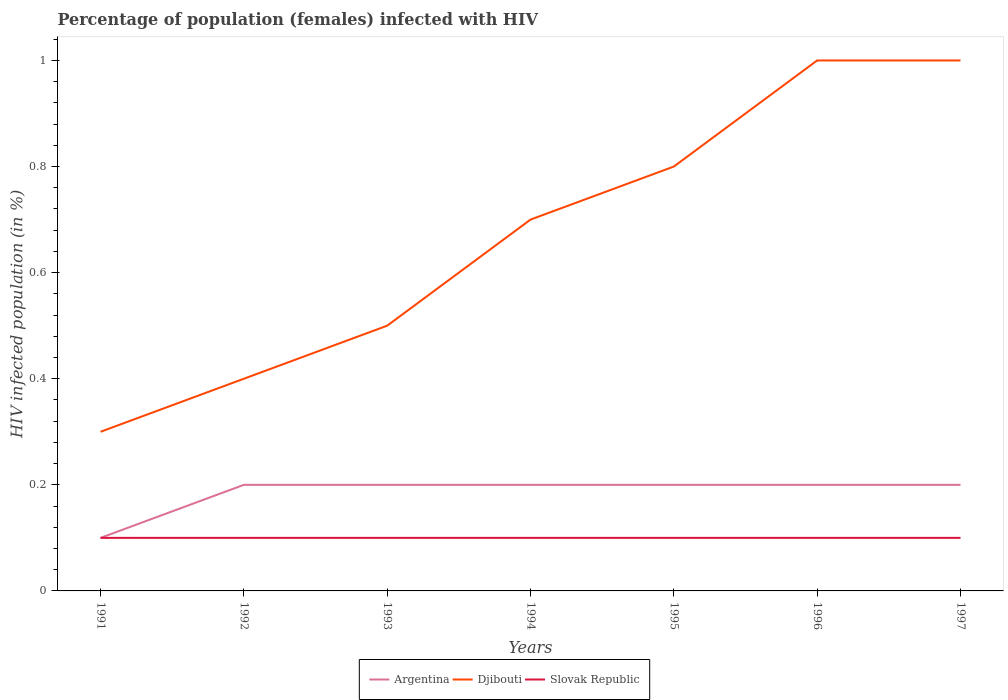Does the line corresponding to Djibouti intersect with the line corresponding to Slovak Republic?
Your response must be concise. No. Across all years, what is the maximum percentage of HIV infected female population in Argentina?
Give a very brief answer. 0.1. Is the percentage of HIV infected female population in Djibouti strictly greater than the percentage of HIV infected female population in Argentina over the years?
Offer a very short reply. No. Does the graph contain any zero values?
Give a very brief answer. No. Does the graph contain grids?
Offer a very short reply. No. Where does the legend appear in the graph?
Provide a succinct answer. Bottom center. How many legend labels are there?
Keep it short and to the point. 3. How are the legend labels stacked?
Provide a short and direct response. Horizontal. What is the title of the graph?
Give a very brief answer. Percentage of population (females) infected with HIV. Does "Vanuatu" appear as one of the legend labels in the graph?
Your answer should be very brief. No. What is the label or title of the Y-axis?
Give a very brief answer. HIV infected population (in %). What is the HIV infected population (in %) in Argentina in 1991?
Provide a short and direct response. 0.1. What is the HIV infected population (in %) in Djibouti in 1991?
Offer a terse response. 0.3. What is the HIV infected population (in %) in Slovak Republic in 1991?
Your answer should be compact. 0.1. What is the HIV infected population (in %) of Argentina in 1993?
Offer a terse response. 0.2. What is the HIV infected population (in %) of Slovak Republic in 1993?
Your answer should be compact. 0.1. What is the HIV infected population (in %) in Djibouti in 1994?
Make the answer very short. 0.7. What is the HIV infected population (in %) in Argentina in 1996?
Provide a succinct answer. 0.2. What is the HIV infected population (in %) in Slovak Republic in 1996?
Your answer should be very brief. 0.1. What is the HIV infected population (in %) of Argentina in 1997?
Offer a very short reply. 0.2. What is the HIV infected population (in %) of Djibouti in 1997?
Offer a terse response. 1. Across all years, what is the maximum HIV infected population (in %) in Djibouti?
Your answer should be very brief. 1. Across all years, what is the maximum HIV infected population (in %) in Slovak Republic?
Ensure brevity in your answer.  0.1. Across all years, what is the minimum HIV infected population (in %) of Argentina?
Offer a very short reply. 0.1. Across all years, what is the minimum HIV infected population (in %) of Slovak Republic?
Make the answer very short. 0.1. What is the total HIV infected population (in %) in Slovak Republic in the graph?
Your answer should be very brief. 0.7. What is the difference between the HIV infected population (in %) in Argentina in 1991 and that in 1992?
Offer a very short reply. -0.1. What is the difference between the HIV infected population (in %) in Slovak Republic in 1991 and that in 1993?
Offer a very short reply. 0. What is the difference between the HIV infected population (in %) of Argentina in 1991 and that in 1994?
Make the answer very short. -0.1. What is the difference between the HIV infected population (in %) in Djibouti in 1991 and that in 1995?
Offer a very short reply. -0.5. What is the difference between the HIV infected population (in %) of Slovak Republic in 1991 and that in 1995?
Your answer should be compact. 0. What is the difference between the HIV infected population (in %) in Djibouti in 1991 and that in 1996?
Keep it short and to the point. -0.7. What is the difference between the HIV infected population (in %) in Slovak Republic in 1991 and that in 1996?
Make the answer very short. 0. What is the difference between the HIV infected population (in %) of Djibouti in 1991 and that in 1997?
Your response must be concise. -0.7. What is the difference between the HIV infected population (in %) in Argentina in 1992 and that in 1993?
Give a very brief answer. 0. What is the difference between the HIV infected population (in %) in Slovak Republic in 1992 and that in 1993?
Your answer should be very brief. 0. What is the difference between the HIV infected population (in %) in Argentina in 1992 and that in 1994?
Offer a terse response. 0. What is the difference between the HIV infected population (in %) of Djibouti in 1992 and that in 1995?
Offer a very short reply. -0.4. What is the difference between the HIV infected population (in %) in Slovak Republic in 1992 and that in 1995?
Your answer should be compact. 0. What is the difference between the HIV infected population (in %) of Djibouti in 1992 and that in 1996?
Keep it short and to the point. -0.6. What is the difference between the HIV infected population (in %) in Argentina in 1992 and that in 1997?
Provide a succinct answer. 0. What is the difference between the HIV infected population (in %) of Slovak Republic in 1993 and that in 1994?
Your answer should be compact. 0. What is the difference between the HIV infected population (in %) in Djibouti in 1993 and that in 1995?
Keep it short and to the point. -0.3. What is the difference between the HIV infected population (in %) of Argentina in 1993 and that in 1996?
Offer a terse response. 0. What is the difference between the HIV infected population (in %) in Slovak Republic in 1993 and that in 1996?
Ensure brevity in your answer.  0. What is the difference between the HIV infected population (in %) of Argentina in 1993 and that in 1997?
Your answer should be very brief. 0. What is the difference between the HIV infected population (in %) in Djibouti in 1993 and that in 1997?
Make the answer very short. -0.5. What is the difference between the HIV infected population (in %) of Slovak Republic in 1993 and that in 1997?
Give a very brief answer. 0. What is the difference between the HIV infected population (in %) of Argentina in 1994 and that in 1995?
Provide a short and direct response. 0. What is the difference between the HIV infected population (in %) in Djibouti in 1994 and that in 1995?
Keep it short and to the point. -0.1. What is the difference between the HIV infected population (in %) of Argentina in 1994 and that in 1997?
Keep it short and to the point. 0. What is the difference between the HIV infected population (in %) of Slovak Republic in 1994 and that in 1997?
Offer a very short reply. 0. What is the difference between the HIV infected population (in %) in Djibouti in 1995 and that in 1996?
Your answer should be very brief. -0.2. What is the difference between the HIV infected population (in %) in Argentina in 1995 and that in 1997?
Offer a very short reply. 0. What is the difference between the HIV infected population (in %) in Djibouti in 1995 and that in 1997?
Offer a very short reply. -0.2. What is the difference between the HIV infected population (in %) of Djibouti in 1996 and that in 1997?
Provide a succinct answer. 0. What is the difference between the HIV infected population (in %) in Slovak Republic in 1996 and that in 1997?
Offer a very short reply. 0. What is the difference between the HIV infected population (in %) of Argentina in 1991 and the HIV infected population (in %) of Slovak Republic in 1992?
Ensure brevity in your answer.  0. What is the difference between the HIV infected population (in %) of Argentina in 1991 and the HIV infected population (in %) of Slovak Republic in 1994?
Make the answer very short. 0. What is the difference between the HIV infected population (in %) of Argentina in 1991 and the HIV infected population (in %) of Djibouti in 1995?
Ensure brevity in your answer.  -0.7. What is the difference between the HIV infected population (in %) in Argentina in 1991 and the HIV infected population (in %) in Djibouti in 1996?
Provide a succinct answer. -0.9. What is the difference between the HIV infected population (in %) of Argentina in 1992 and the HIV infected population (in %) of Slovak Republic in 1993?
Provide a short and direct response. 0.1. What is the difference between the HIV infected population (in %) in Djibouti in 1992 and the HIV infected population (in %) in Slovak Republic in 1993?
Provide a short and direct response. 0.3. What is the difference between the HIV infected population (in %) of Djibouti in 1992 and the HIV infected population (in %) of Slovak Republic in 1994?
Your answer should be very brief. 0.3. What is the difference between the HIV infected population (in %) of Argentina in 1992 and the HIV infected population (in %) of Djibouti in 1995?
Ensure brevity in your answer.  -0.6. What is the difference between the HIV infected population (in %) of Argentina in 1992 and the HIV infected population (in %) of Slovak Republic in 1995?
Offer a terse response. 0.1. What is the difference between the HIV infected population (in %) of Argentina in 1992 and the HIV infected population (in %) of Slovak Republic in 1996?
Make the answer very short. 0.1. What is the difference between the HIV infected population (in %) in Argentina in 1992 and the HIV infected population (in %) in Djibouti in 1997?
Your answer should be compact. -0.8. What is the difference between the HIV infected population (in %) in Argentina in 1992 and the HIV infected population (in %) in Slovak Republic in 1997?
Ensure brevity in your answer.  0.1. What is the difference between the HIV infected population (in %) of Djibouti in 1992 and the HIV infected population (in %) of Slovak Republic in 1997?
Provide a succinct answer. 0.3. What is the difference between the HIV infected population (in %) of Argentina in 1993 and the HIV infected population (in %) of Djibouti in 1994?
Provide a succinct answer. -0.5. What is the difference between the HIV infected population (in %) in Djibouti in 1993 and the HIV infected population (in %) in Slovak Republic in 1995?
Make the answer very short. 0.4. What is the difference between the HIV infected population (in %) in Djibouti in 1993 and the HIV infected population (in %) in Slovak Republic in 1996?
Make the answer very short. 0.4. What is the difference between the HIV infected population (in %) in Argentina in 1993 and the HIV infected population (in %) in Djibouti in 1997?
Provide a short and direct response. -0.8. What is the difference between the HIV infected population (in %) in Argentina in 1993 and the HIV infected population (in %) in Slovak Republic in 1997?
Your answer should be very brief. 0.1. What is the difference between the HIV infected population (in %) in Djibouti in 1993 and the HIV infected population (in %) in Slovak Republic in 1997?
Your answer should be compact. 0.4. What is the difference between the HIV infected population (in %) of Argentina in 1994 and the HIV infected population (in %) of Djibouti in 1995?
Ensure brevity in your answer.  -0.6. What is the difference between the HIV infected population (in %) of Argentina in 1994 and the HIV infected population (in %) of Slovak Republic in 1995?
Ensure brevity in your answer.  0.1. What is the difference between the HIV infected population (in %) in Djibouti in 1994 and the HIV infected population (in %) in Slovak Republic in 1995?
Your answer should be compact. 0.6. What is the difference between the HIV infected population (in %) in Argentina in 1994 and the HIV infected population (in %) in Djibouti in 1996?
Your answer should be compact. -0.8. What is the difference between the HIV infected population (in %) of Djibouti in 1994 and the HIV infected population (in %) of Slovak Republic in 1996?
Offer a terse response. 0.6. What is the difference between the HIV infected population (in %) in Djibouti in 1994 and the HIV infected population (in %) in Slovak Republic in 1997?
Your response must be concise. 0.6. What is the difference between the HIV infected population (in %) in Argentina in 1995 and the HIV infected population (in %) in Djibouti in 1996?
Make the answer very short. -0.8. What is the difference between the HIV infected population (in %) in Argentina in 1995 and the HIV infected population (in %) in Slovak Republic in 1996?
Your answer should be very brief. 0.1. What is the difference between the HIV infected population (in %) in Djibouti in 1995 and the HIV infected population (in %) in Slovak Republic in 1997?
Give a very brief answer. 0.7. What is the difference between the HIV infected population (in %) in Argentina in 1996 and the HIV infected population (in %) in Djibouti in 1997?
Offer a very short reply. -0.8. What is the difference between the HIV infected population (in %) in Djibouti in 1996 and the HIV infected population (in %) in Slovak Republic in 1997?
Make the answer very short. 0.9. What is the average HIV infected population (in %) of Argentina per year?
Keep it short and to the point. 0.19. What is the average HIV infected population (in %) in Djibouti per year?
Your answer should be very brief. 0.67. What is the average HIV infected population (in %) of Slovak Republic per year?
Give a very brief answer. 0.1. In the year 1991, what is the difference between the HIV infected population (in %) in Argentina and HIV infected population (in %) in Djibouti?
Your response must be concise. -0.2. In the year 1991, what is the difference between the HIV infected population (in %) in Djibouti and HIV infected population (in %) in Slovak Republic?
Give a very brief answer. 0.2. In the year 1992, what is the difference between the HIV infected population (in %) in Argentina and HIV infected population (in %) in Slovak Republic?
Your response must be concise. 0.1. In the year 1993, what is the difference between the HIV infected population (in %) in Djibouti and HIV infected population (in %) in Slovak Republic?
Your response must be concise. 0.4. In the year 1995, what is the difference between the HIV infected population (in %) of Argentina and HIV infected population (in %) of Slovak Republic?
Ensure brevity in your answer.  0.1. In the year 1995, what is the difference between the HIV infected population (in %) in Djibouti and HIV infected population (in %) in Slovak Republic?
Offer a terse response. 0.7. In the year 1996, what is the difference between the HIV infected population (in %) of Argentina and HIV infected population (in %) of Djibouti?
Provide a short and direct response. -0.8. In the year 1997, what is the difference between the HIV infected population (in %) in Argentina and HIV infected population (in %) in Djibouti?
Ensure brevity in your answer.  -0.8. What is the ratio of the HIV infected population (in %) in Argentina in 1991 to that in 1992?
Keep it short and to the point. 0.5. What is the ratio of the HIV infected population (in %) of Argentina in 1991 to that in 1993?
Make the answer very short. 0.5. What is the ratio of the HIV infected population (in %) of Djibouti in 1991 to that in 1993?
Give a very brief answer. 0.6. What is the ratio of the HIV infected population (in %) of Djibouti in 1991 to that in 1994?
Offer a terse response. 0.43. What is the ratio of the HIV infected population (in %) of Slovak Republic in 1991 to that in 1994?
Your answer should be very brief. 1. What is the ratio of the HIV infected population (in %) in Djibouti in 1991 to that in 1995?
Provide a succinct answer. 0.38. What is the ratio of the HIV infected population (in %) of Argentina in 1991 to that in 1996?
Keep it short and to the point. 0.5. What is the ratio of the HIV infected population (in %) in Djibouti in 1991 to that in 1996?
Keep it short and to the point. 0.3. What is the ratio of the HIV infected population (in %) of Argentina in 1991 to that in 1997?
Your answer should be compact. 0.5. What is the ratio of the HIV infected population (in %) of Djibouti in 1991 to that in 1997?
Ensure brevity in your answer.  0.3. What is the ratio of the HIV infected population (in %) of Slovak Republic in 1992 to that in 1993?
Ensure brevity in your answer.  1. What is the ratio of the HIV infected population (in %) in Djibouti in 1992 to that in 1994?
Offer a very short reply. 0.57. What is the ratio of the HIV infected population (in %) in Slovak Republic in 1992 to that in 1994?
Your answer should be very brief. 1. What is the ratio of the HIV infected population (in %) in Argentina in 1992 to that in 1995?
Make the answer very short. 1. What is the ratio of the HIV infected population (in %) in Slovak Republic in 1992 to that in 1995?
Offer a terse response. 1. What is the ratio of the HIV infected population (in %) of Djibouti in 1992 to that in 1996?
Offer a very short reply. 0.4. What is the ratio of the HIV infected population (in %) of Argentina in 1992 to that in 1997?
Provide a short and direct response. 1. What is the ratio of the HIV infected population (in %) of Argentina in 1993 to that in 1994?
Provide a succinct answer. 1. What is the ratio of the HIV infected population (in %) in Slovak Republic in 1993 to that in 1994?
Keep it short and to the point. 1. What is the ratio of the HIV infected population (in %) of Argentina in 1993 to that in 1995?
Offer a very short reply. 1. What is the ratio of the HIV infected population (in %) in Djibouti in 1993 to that in 1995?
Give a very brief answer. 0.62. What is the ratio of the HIV infected population (in %) of Argentina in 1993 to that in 1996?
Offer a very short reply. 1. What is the ratio of the HIV infected population (in %) of Argentina in 1993 to that in 1997?
Your answer should be compact. 1. What is the ratio of the HIV infected population (in %) in Slovak Republic in 1993 to that in 1997?
Give a very brief answer. 1. What is the ratio of the HIV infected population (in %) in Djibouti in 1994 to that in 1995?
Provide a succinct answer. 0.88. What is the ratio of the HIV infected population (in %) of Slovak Republic in 1994 to that in 1995?
Provide a short and direct response. 1. What is the ratio of the HIV infected population (in %) in Argentina in 1994 to that in 1996?
Your answer should be compact. 1. What is the ratio of the HIV infected population (in %) in Djibouti in 1994 to that in 1997?
Offer a very short reply. 0.7. What is the ratio of the HIV infected population (in %) of Slovak Republic in 1994 to that in 1997?
Provide a succinct answer. 1. What is the ratio of the HIV infected population (in %) of Slovak Republic in 1995 to that in 1996?
Offer a terse response. 1. What is the ratio of the HIV infected population (in %) of Argentina in 1995 to that in 1997?
Ensure brevity in your answer.  1. What is the ratio of the HIV infected population (in %) in Djibouti in 1995 to that in 1997?
Keep it short and to the point. 0.8. What is the ratio of the HIV infected population (in %) in Argentina in 1996 to that in 1997?
Your response must be concise. 1. What is the ratio of the HIV infected population (in %) of Djibouti in 1996 to that in 1997?
Your answer should be very brief. 1. What is the ratio of the HIV infected population (in %) of Slovak Republic in 1996 to that in 1997?
Ensure brevity in your answer.  1. What is the difference between the highest and the second highest HIV infected population (in %) of Djibouti?
Your answer should be very brief. 0. What is the difference between the highest and the second highest HIV infected population (in %) in Slovak Republic?
Your answer should be very brief. 0. What is the difference between the highest and the lowest HIV infected population (in %) in Djibouti?
Your answer should be compact. 0.7. 